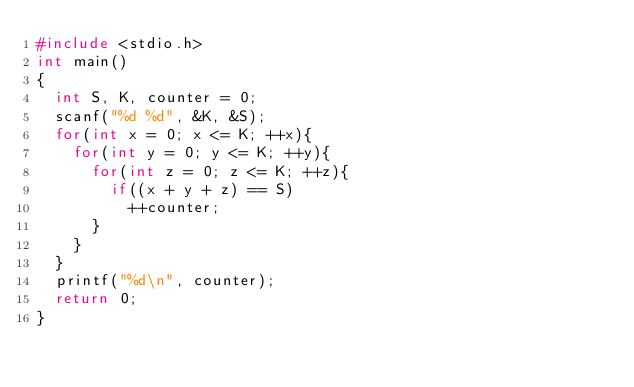Convert code to text. <code><loc_0><loc_0><loc_500><loc_500><_C_>#include <stdio.h>
int main()
{
  int S, K, counter = 0;
  scanf("%d %d", &K, &S);
  for(int x = 0; x <= K; ++x){
    for(int y = 0; y <= K; ++y){
      for(int z = 0; z <= K; ++z){
        if((x + y + z) == S)
          ++counter;
      }
    }
  }
  printf("%d\n", counter);
  return 0;
}</code> 